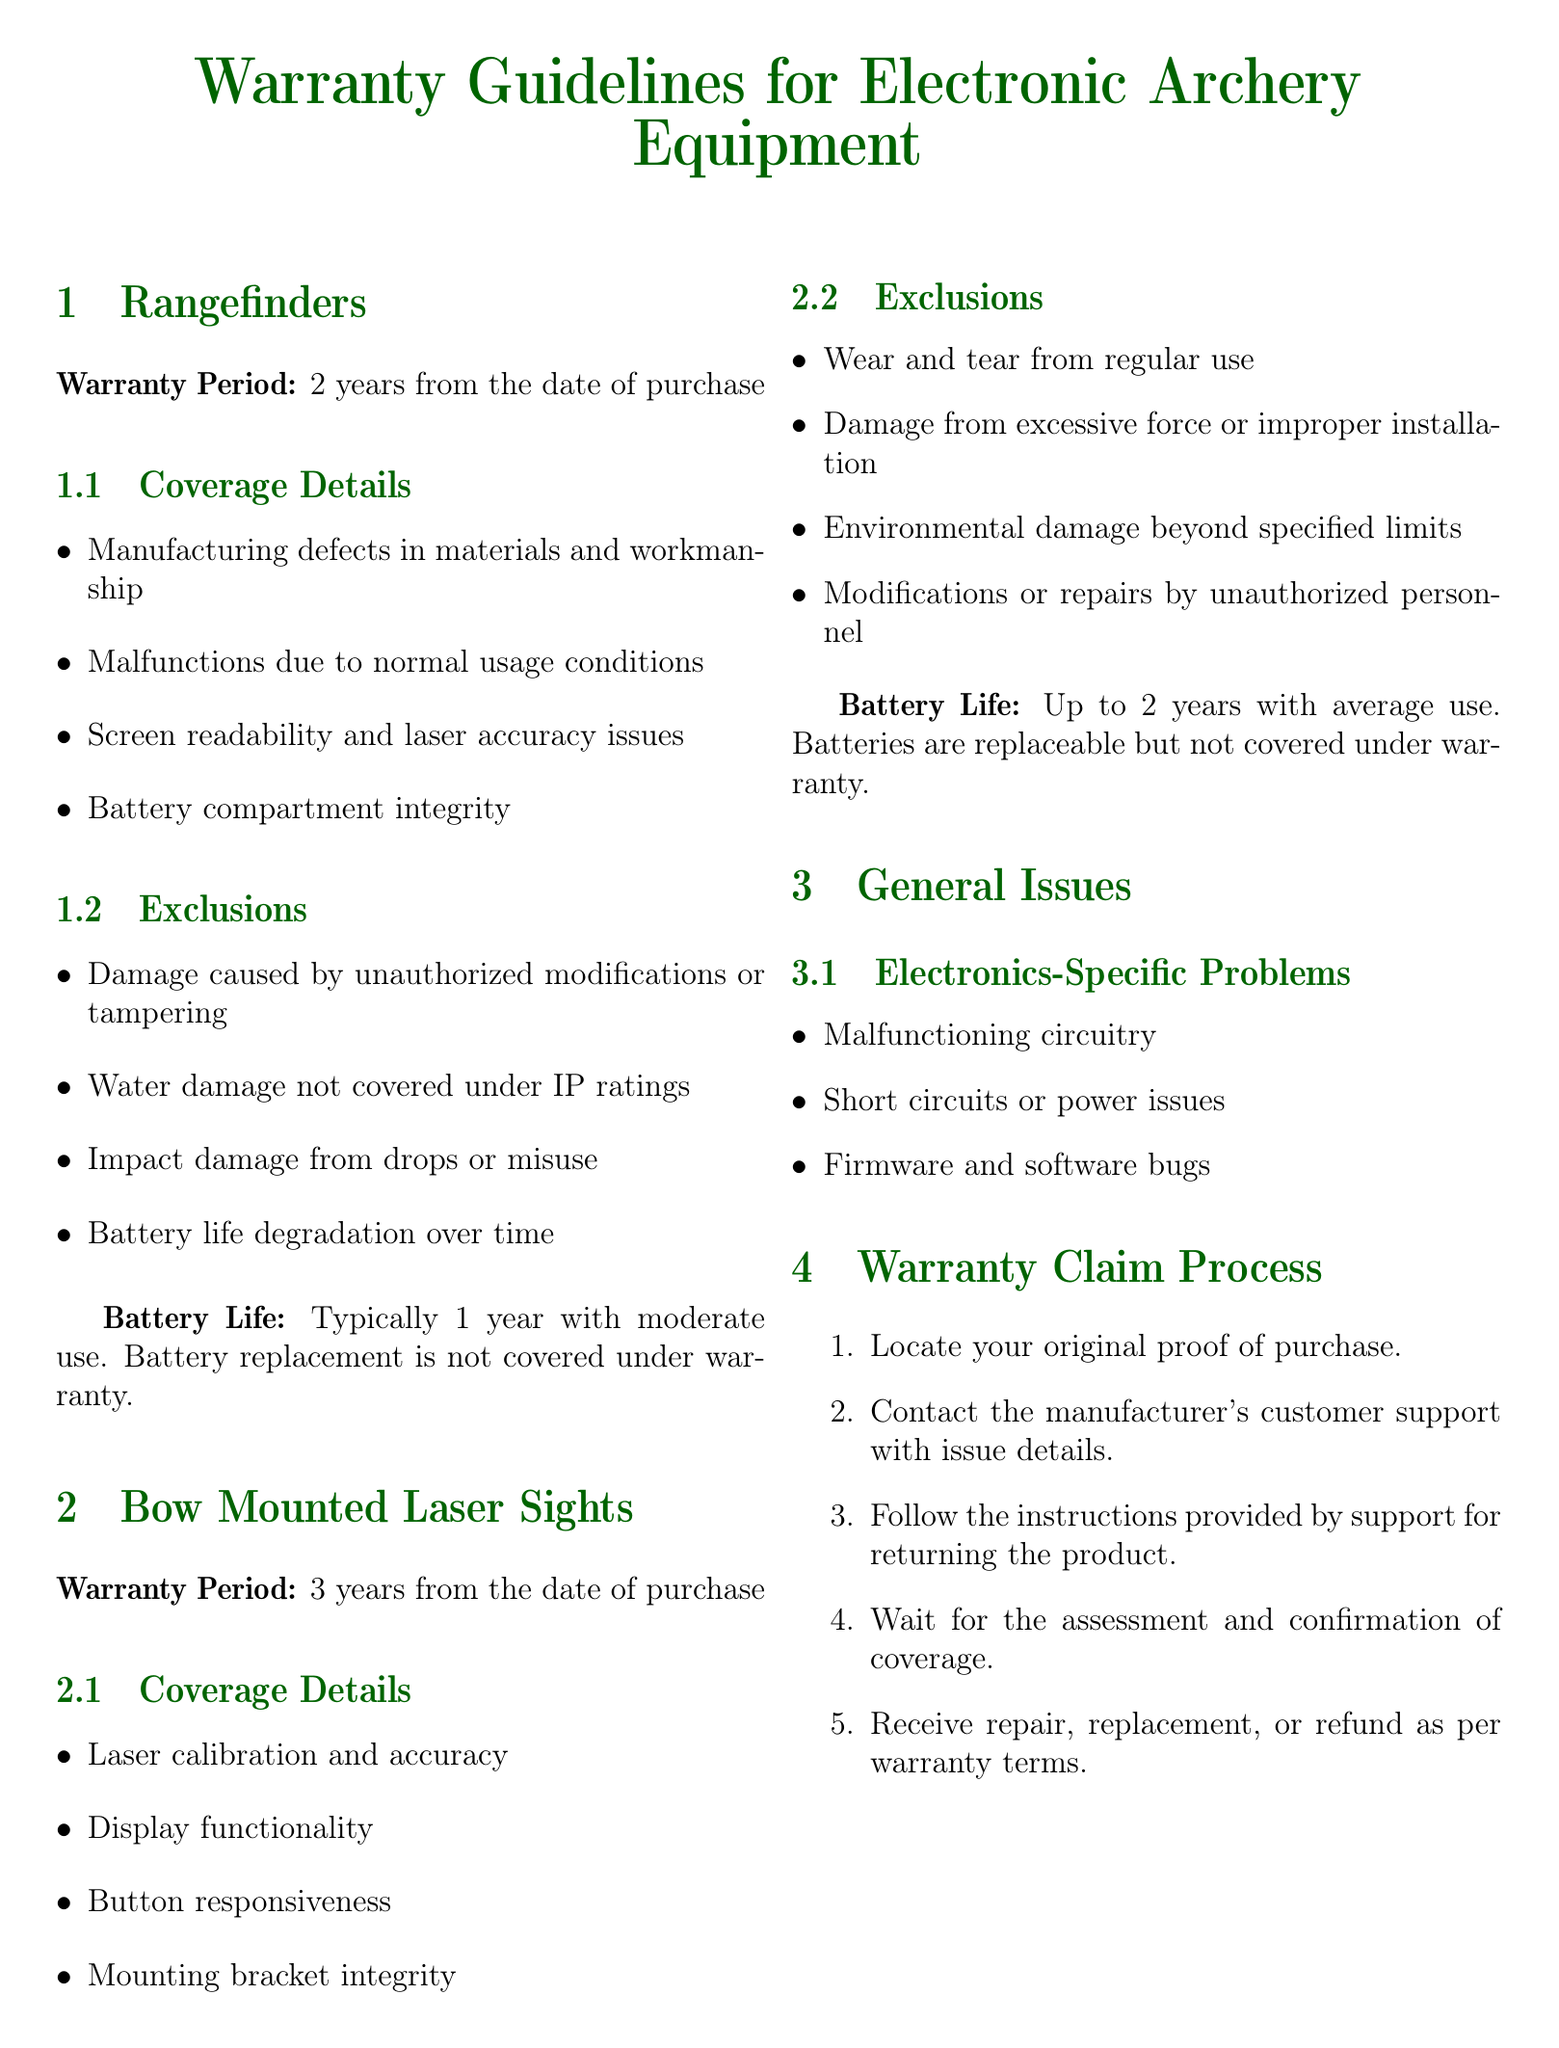What is the warranty period for rangefinders? The warranty period for rangefinders is mentioned in the document as 2 years from the date of purchase.
Answer: 2 years What issues are excluded from the warranty coverage for bow-mounted laser sights? The document lists exclusions for bow-mounted laser sights, such as wear and tear from regular use, damage from excessive force or improper installation, and damage from unauthorized modifications.
Answer: Wear and tear from regular use What is the typical battery life for rangefinders? The document states that the typical battery life for rangefinders is one year with moderate use.
Answer: 1 year How long is the warranty period for bow-mounted laser sights? The warranty period for bow-mounted laser sights is indicated in the document as 3 years from the date of purchase.
Answer: 3 years What is required to initiate a warranty claim? The first step in the warranty claim process is locating the original proof of purchase as outlined in the document.
Answer: Original proof of purchase What type of electronic problems are covered under the warranty? The document specifies that malfunctioning circuitry, short circuits, and firmware bugs are covered under warranty.
Answer: Malfunctioning circuitry Which brand is listed for bow-mounted laser sights? The document lists Garmin Xero A1i as one of the brands for bow-mounted laser sights.
Answer: Garmin Xero A1i What happens if casing is damaged from drops? The document states that damage caused by drops or misuse is excluded from warranty coverage.
Answer: Excluded What must a customer do after contacting support for a warranty claim? According to the document, after contacting support, the customer must follow the instructions provided for returning the product.
Answer: Follow instructions for returning the product 